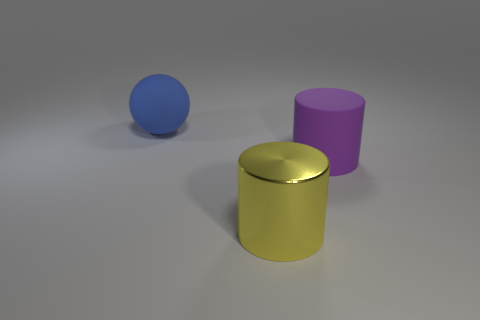Add 1 blue spheres. How many objects exist? 4 Subtract all cylinders. How many objects are left? 1 Subtract all brown spheres. Subtract all red blocks. How many spheres are left? 1 Subtract all blue balls. How many gray cylinders are left? 0 Subtract all big rubber cylinders. Subtract all large rubber cylinders. How many objects are left? 1 Add 3 yellow cylinders. How many yellow cylinders are left? 4 Add 1 big purple cylinders. How many big purple cylinders exist? 2 Subtract 0 brown balls. How many objects are left? 3 